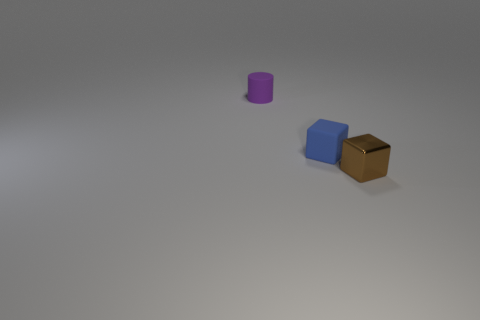There is a brown object that is to the right of the tiny block that is left of the tiny brown block; what size is it?
Your response must be concise. Small. Is there a tiny shiny ball that has the same color as the tiny cylinder?
Ensure brevity in your answer.  No. There is a tiny matte object that is in front of the purple cylinder; is its color the same as the object right of the matte cube?
Keep it short and to the point. No. What is the shape of the blue matte object?
Offer a terse response. Cube. How many blue things are behind the blue thing?
Keep it short and to the point. 0. How many small blue blocks have the same material as the small brown cube?
Offer a terse response. 0. Is the material of the thing that is behind the matte block the same as the brown object?
Ensure brevity in your answer.  No. Are any tiny things visible?
Your response must be concise. Yes. What size is the object that is both to the right of the small purple rubber object and behind the shiny cube?
Your answer should be compact. Small. Are there more purple rubber objects in front of the blue matte thing than small brown objects left of the small metal cube?
Ensure brevity in your answer.  No. 